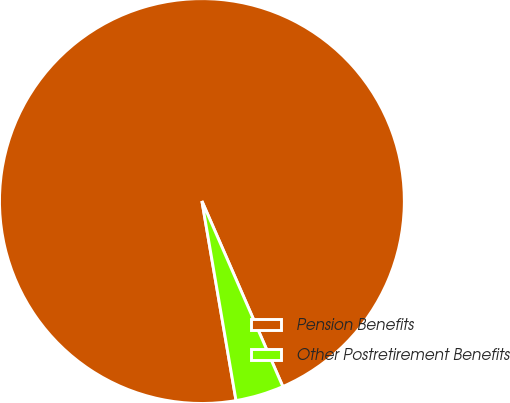Convert chart. <chart><loc_0><loc_0><loc_500><loc_500><pie_chart><fcel>Pension Benefits<fcel>Other Postretirement Benefits<nl><fcel>96.15%<fcel>3.85%<nl></chart> 